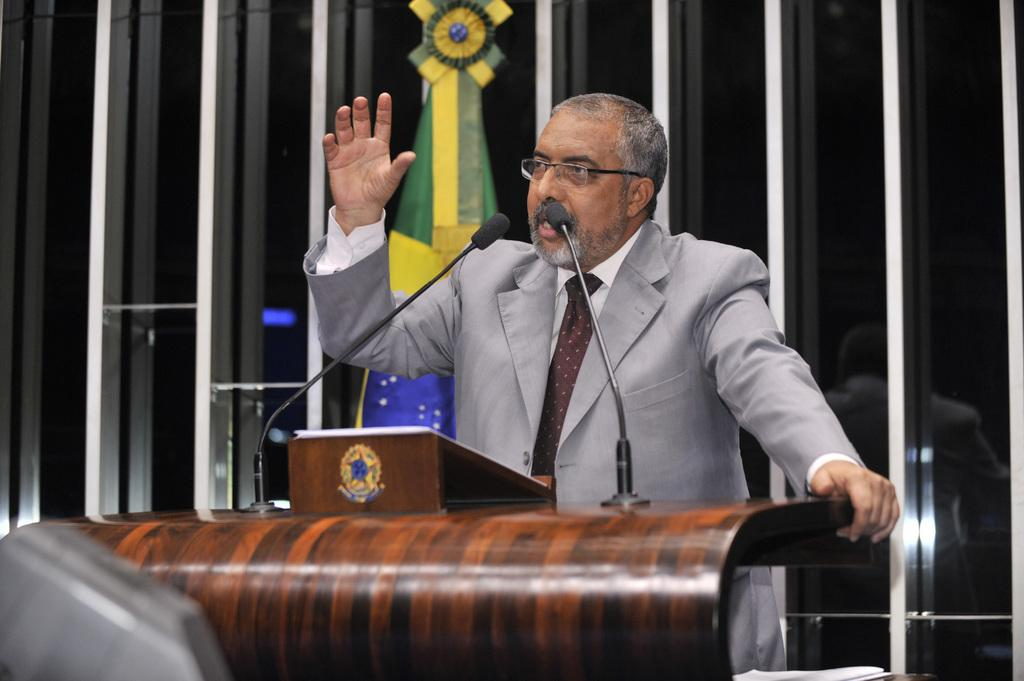What is the person in the image wearing? The person in the image is wearing a coat. What object can be seen in the foreground of the image? There is a wooden podium in the foreground of the image. What device is visible in the image that might be used for amplifying sound? There is a microphone visible in the image. What type of decision can be seen being made in the image? There is no decision-making process visible in the image; it only shows a person wearing a coat, a wooden podium, and a microphone. Can you describe the zephyr present in the image? There is no zephyr present in the image; a zephyr refers to a gentle breeze, and there is no mention of weather or wind in the provided facts. 